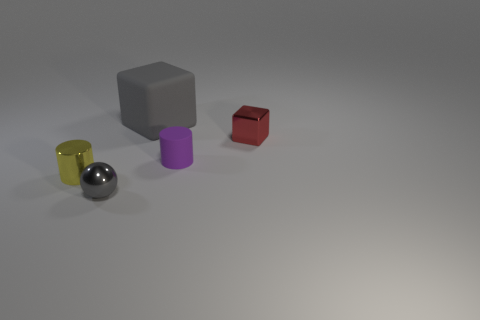How many other shiny things have the same shape as the tiny red thing?
Offer a terse response. 0. Is the color of the shiny cylinder the same as the big matte thing?
Your response must be concise. No. Is there anything else that is the same shape as the tiny gray object?
Ensure brevity in your answer.  No. Is there another thing that has the same color as the large rubber object?
Offer a very short reply. Yes. Do the gray thing that is in front of the tiny metal cube and the small cylinder right of the big gray rubber object have the same material?
Offer a very short reply. No. The small shiny ball is what color?
Your answer should be very brief. Gray. There is a cube in front of the cube that is left of the matte object in front of the red cube; how big is it?
Provide a short and direct response. Small. What number of other things are there of the same size as the gray metal sphere?
Provide a short and direct response. 3. How many tiny purple cylinders are the same material as the small gray sphere?
Make the answer very short. 0. The metal object on the left side of the shiny sphere has what shape?
Give a very brief answer. Cylinder. 